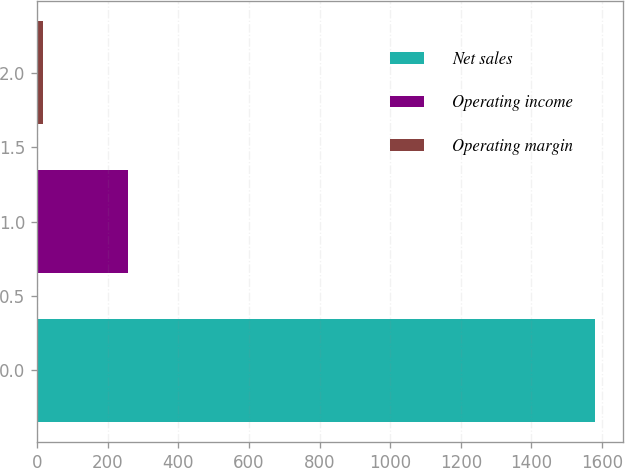<chart> <loc_0><loc_0><loc_500><loc_500><bar_chart><fcel>Net sales<fcel>Operating income<fcel>Operating margin<nl><fcel>1581<fcel>258<fcel>16.3<nl></chart> 